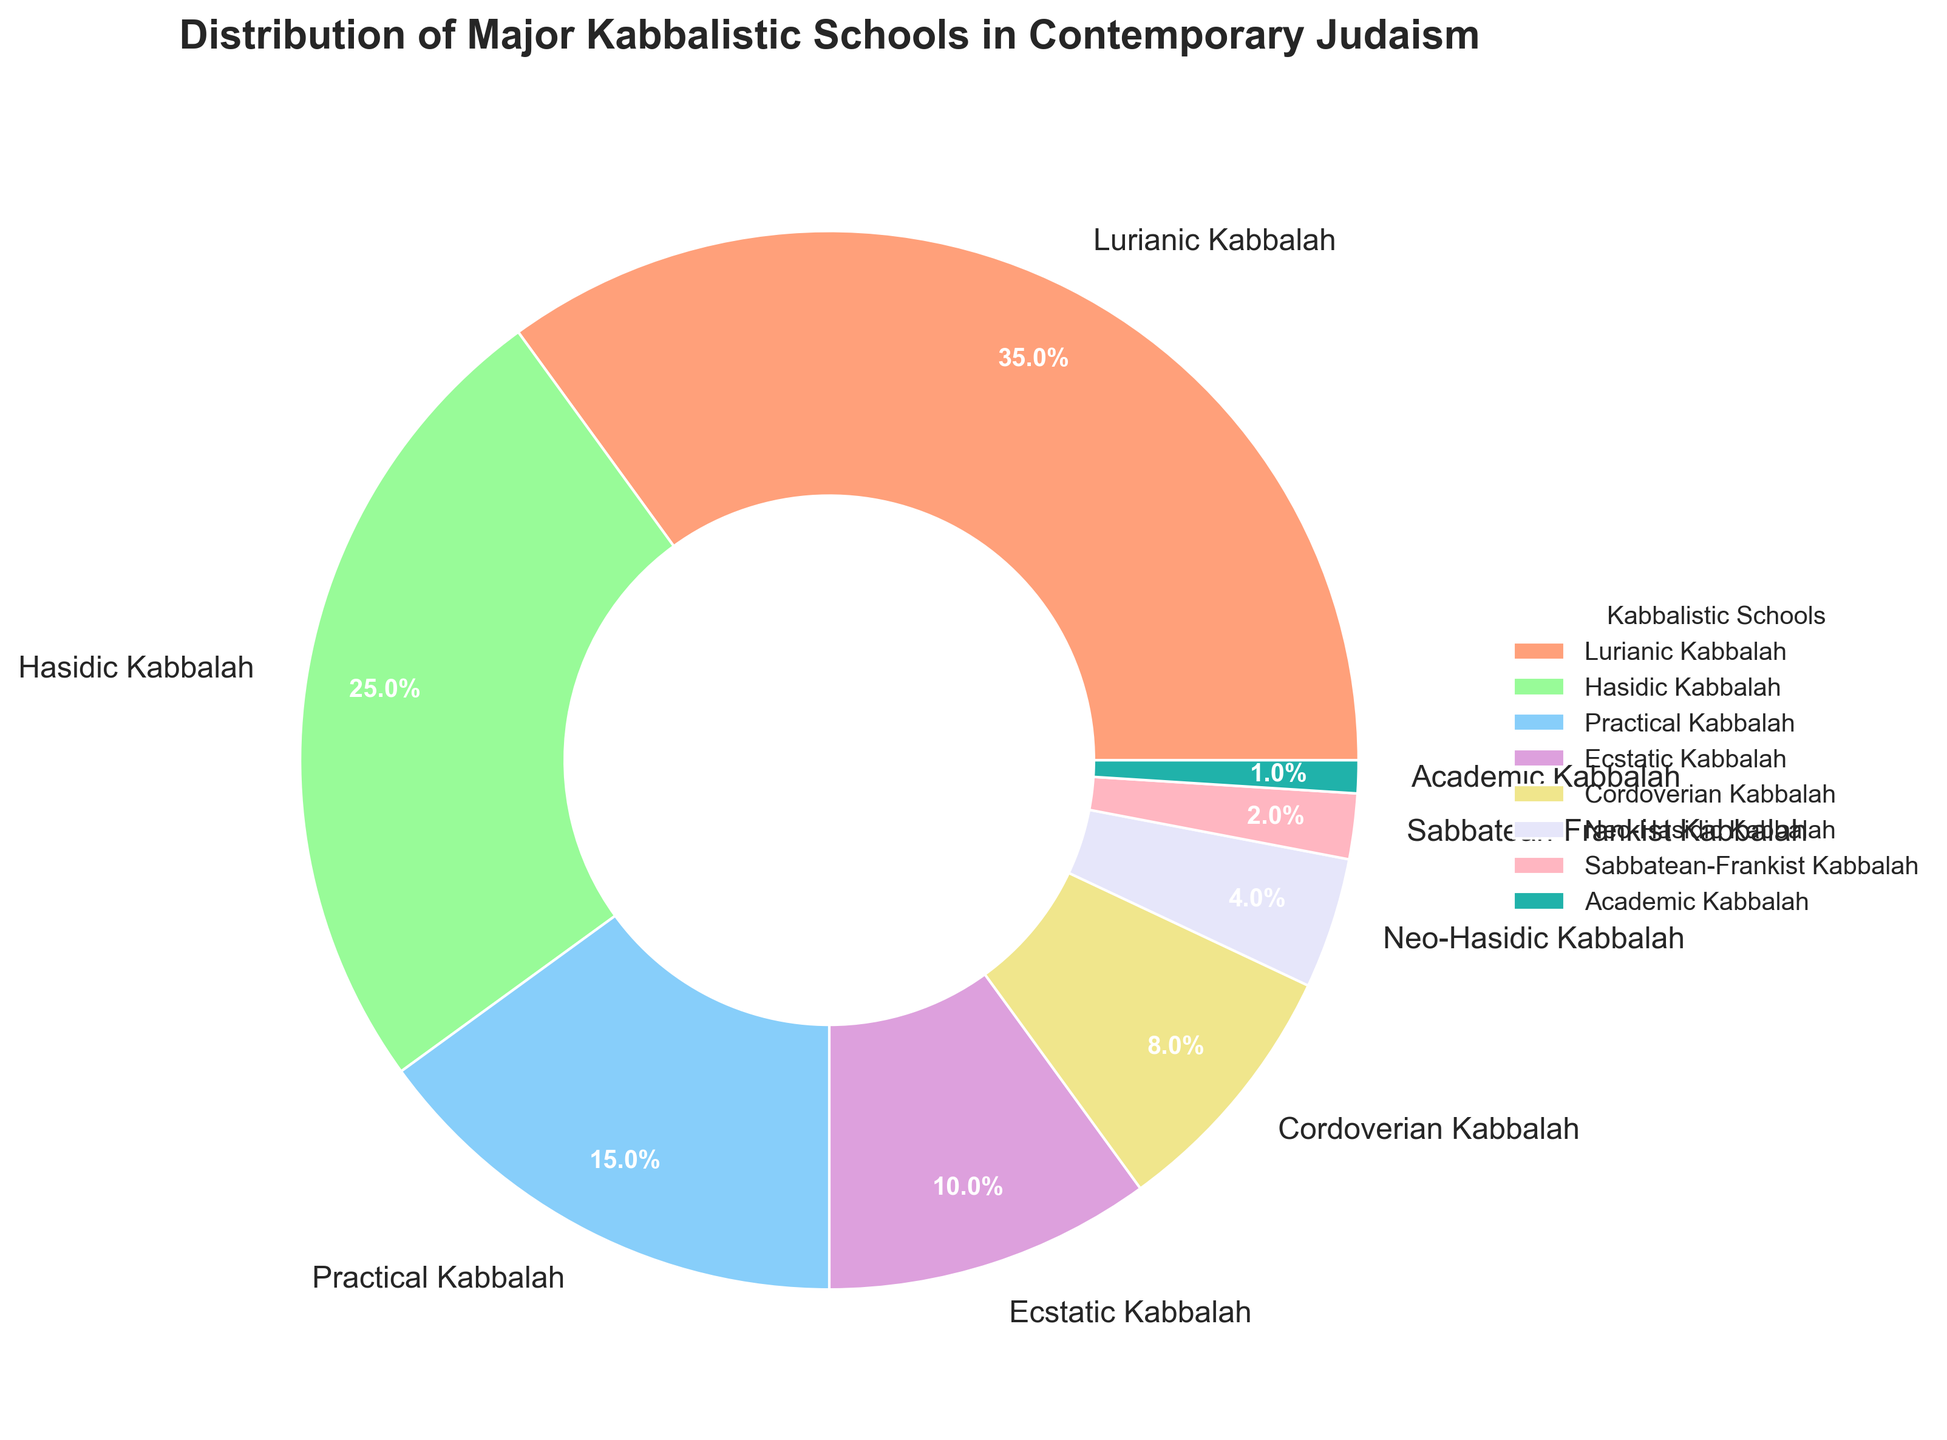Which Kabbalistic school has the highest percentage? The largest segment of the pie chart represents the school with the highest percentage. According to the chart, the Lurianic Kabbalah segment is the largest.
Answer: Lurianic Kabbalah What is the combined percentage of Lurianic and Hasidic Kabbalah? To find the combined percentage, add the individual percentages of Lurianic Kabbalah (35%) and Hasidic Kabbalah (25%). This sums up to 35 + 25 = 60.
Answer: 60% Which school has a smaller percentage, Cordoverian Kabbalah or Practical Kabbalah? By comparing the sizes of the segments, Cordoverian Kabbalah has 8% and Practical Kabbalah has 15%. Therefore, Cordoverian Kabbalah has a smaller percentage.
Answer: Cordoverian Kabbalah How much larger is Hasidic Kabbalah compared to Ecstatic Kabbalah? Subtract the percentage of Ecstatic Kabbalah (10%) from Hasidic Kabbalah (25%) to find the difference: 25 - 10 = 15.
Answer: 15% What percentage of the chart is represented by all schools except for Lurianic Kabbalah? To find this, subtract the percentage of Lurianic Kabbalah (35%) from 100%: 100 - 35 = 65. This represents the combined percentage of all other schools.
Answer: 65% Which segment of the chart is smallest, and what is its percentage? Identifying the smallest segment in the pie chart, Academic Kabbalah occupies the least space with a 1% share.
Answer: Academic Kabbalah, 1% How do Practical and Ecstatic Kabbalah combined compare to Lurianic Kabbalah in percentage? Add the percentages of Practical Kabbalah (15%) and Ecstatic Kabbalah (10%). This gives 15 + 10 = 25. Since Lurianic Kabbalah is 35%, Lurianic Kabbalah is larger.
Answer: Lurianic Kabbalah is larger by 10% What is the average percentage of Neo-Hasidic and Sabbatean-Frankist Kabbalah? Add the percentages of Neo-Hasidic (4%) and Sabbatean-Frankist (2%), then divide by two: (4 + 2) / 2 = 3.
Answer: 3% Which Kabbalistic schools together make up more than half of the chart? The combination of Lurianic Kabbalah (35%) and Hasidic Kabbalah (25%) is 35 + 25 = 60%, which is more than half (50%) of the chart.
Answer: Lurianic Kabbalah, Hasidic Kabbalah 